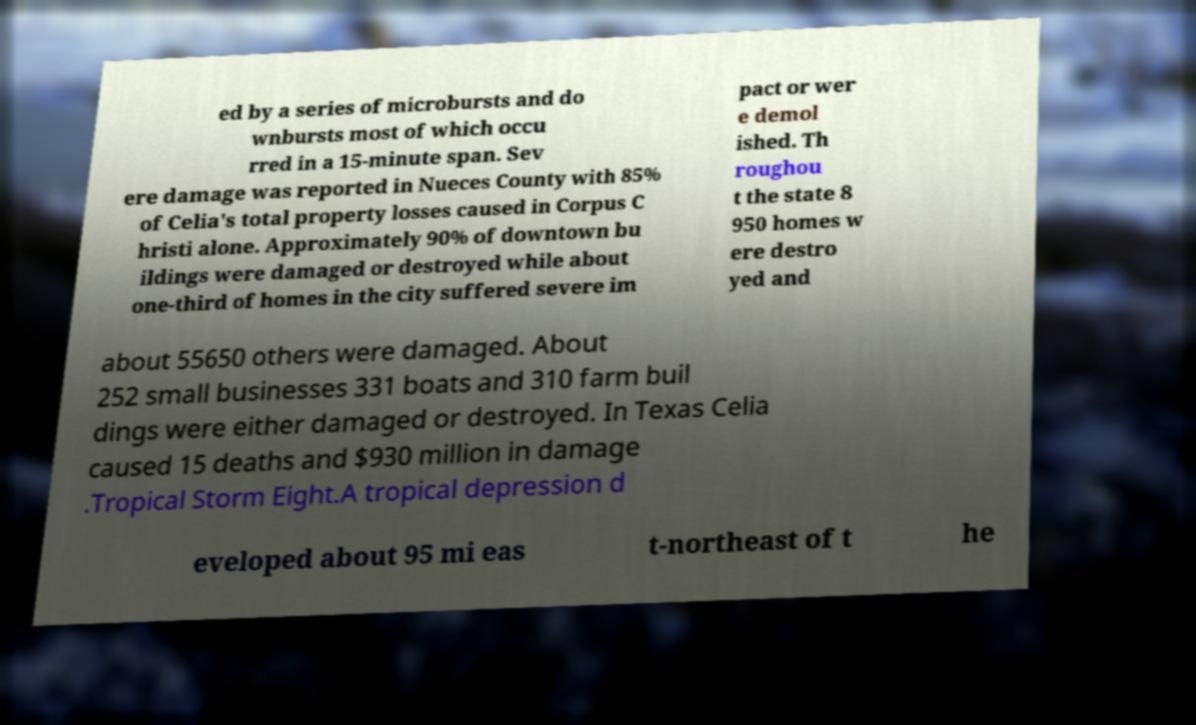Could you assist in decoding the text presented in this image and type it out clearly? ed by a series of microbursts and do wnbursts most of which occu rred in a 15-minute span. Sev ere damage was reported in Nueces County with 85% of Celia's total property losses caused in Corpus C hristi alone. Approximately 90% of downtown bu ildings were damaged or destroyed while about one-third of homes in the city suffered severe im pact or wer e demol ished. Th roughou t the state 8 950 homes w ere destro yed and about 55650 others were damaged. About 252 small businesses 331 boats and 310 farm buil dings were either damaged or destroyed. In Texas Celia caused 15 deaths and $930 million in damage .Tropical Storm Eight.A tropical depression d eveloped about 95 mi eas t-northeast of t he 